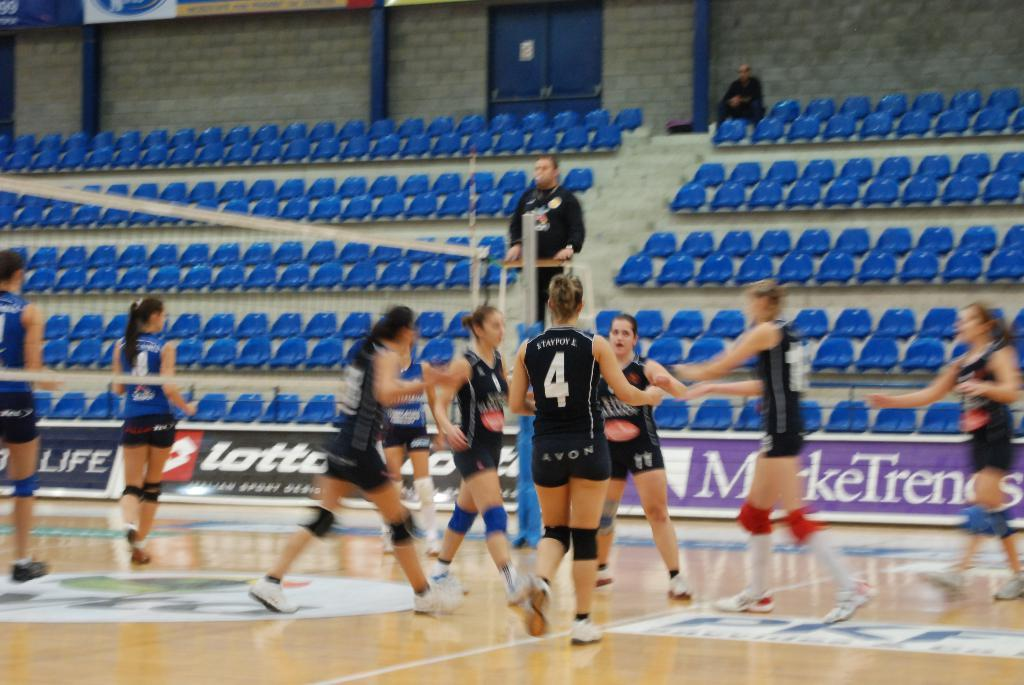Who or what can be seen in the image? There are people in the image. What type of furniture is present in the image? There are sitting chairs in the image. Can you describe the position of the person on the right side of the image? There is a person standing on the right side of the image. What is the position of the person on the left side of the image? There is a person sitting on the right side of the image. What color is the sweater worn by the person sitting on the left side of the image? There is no person sitting on the left side of the image, and there is no mention of a sweater in the provided facts. 